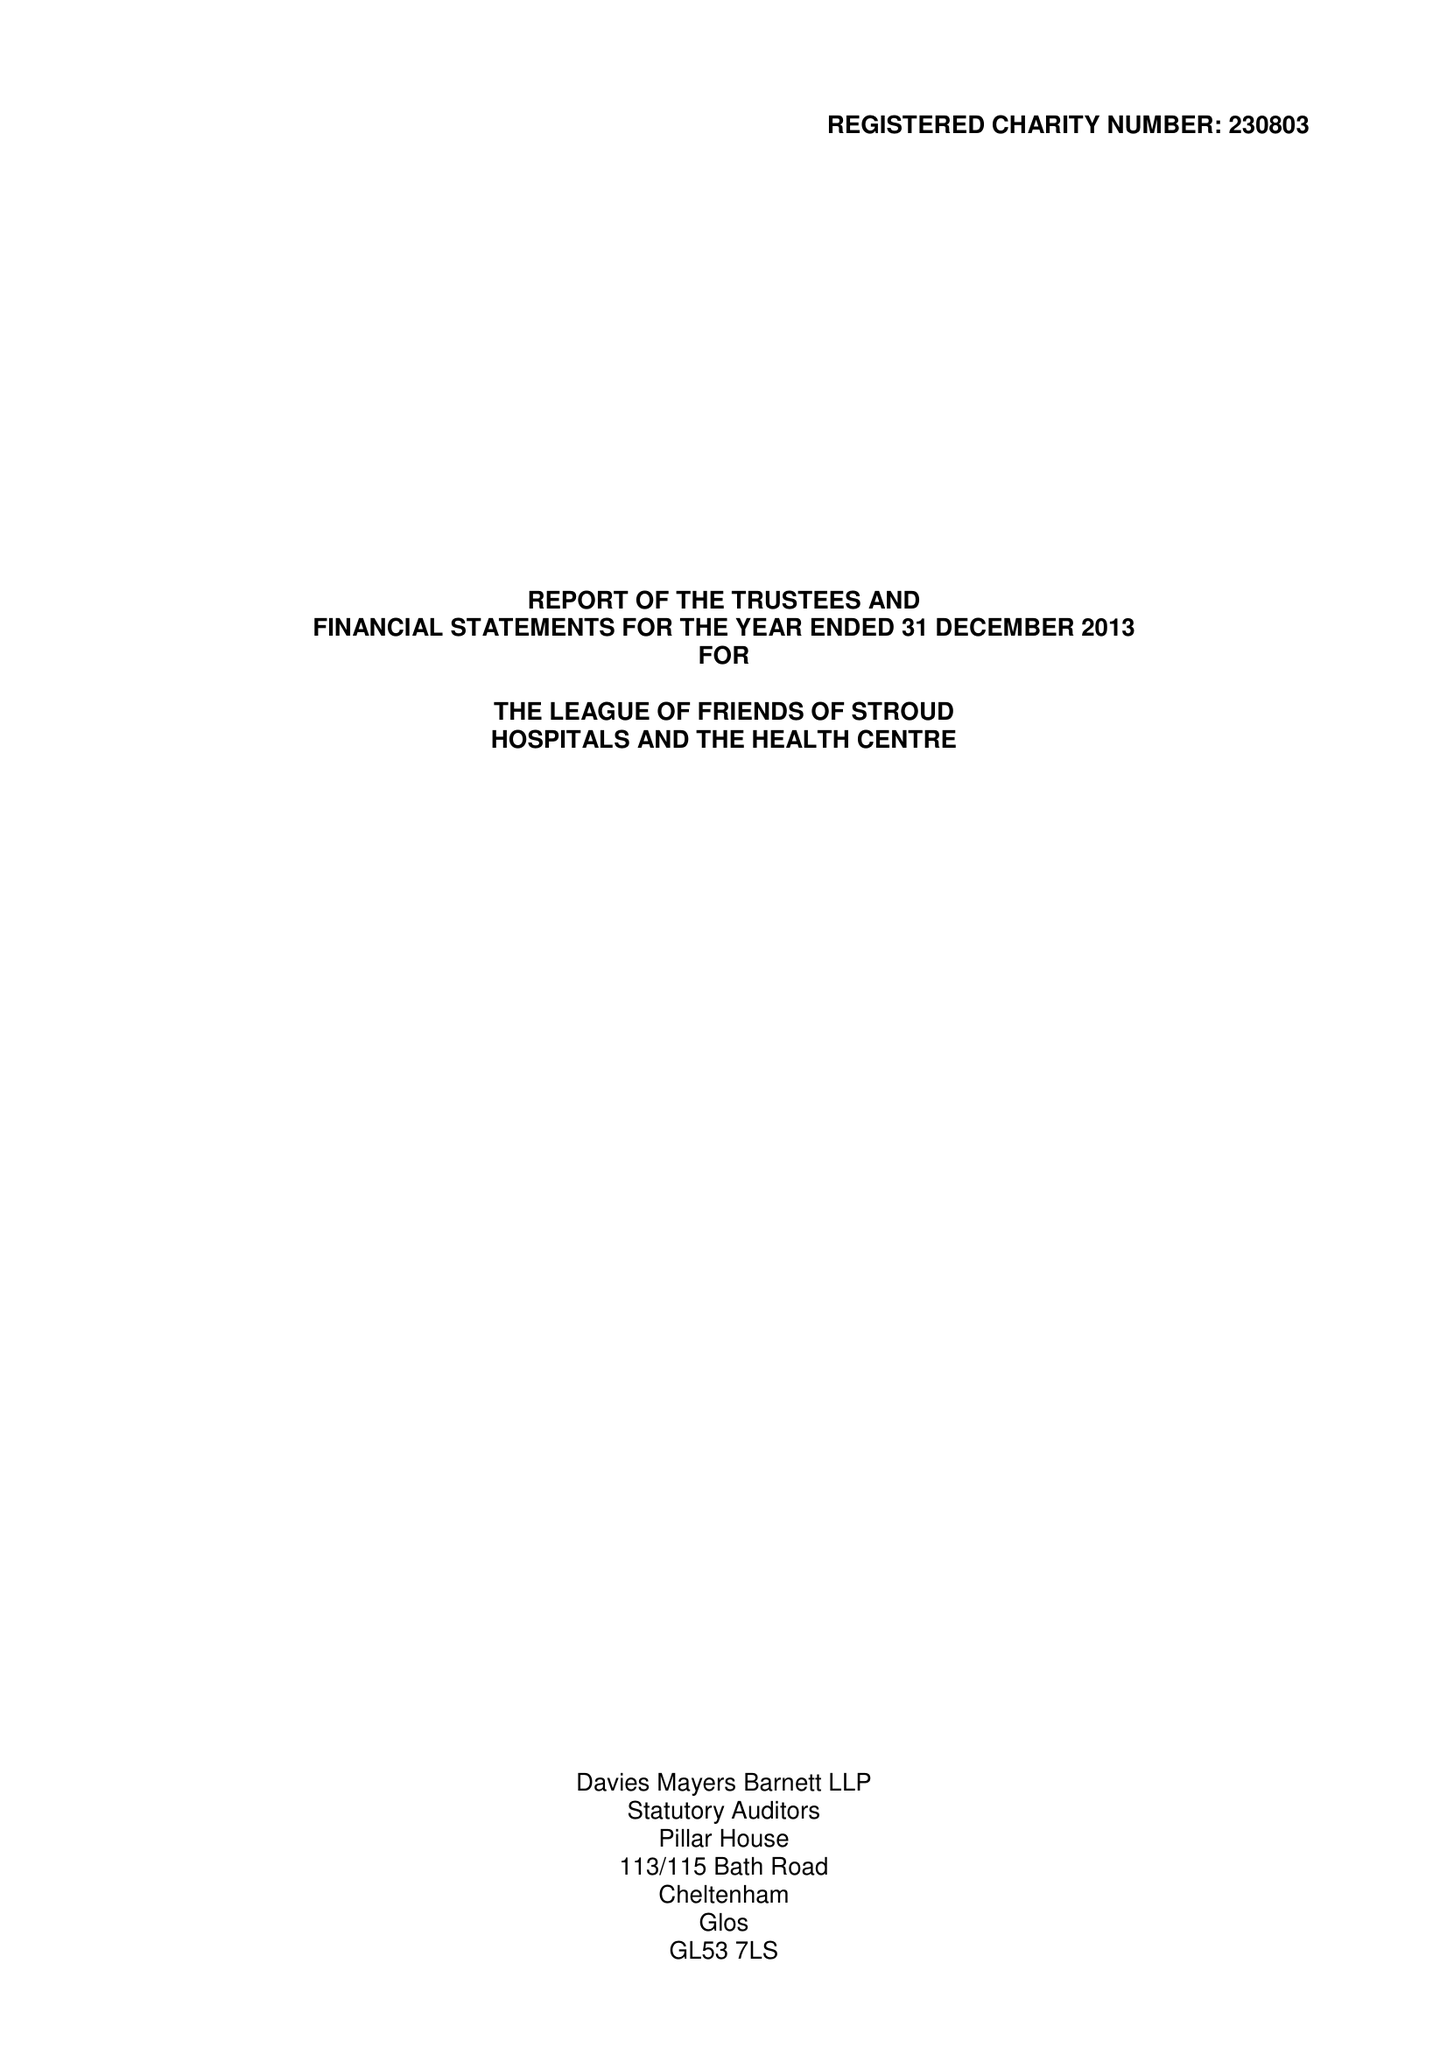What is the value for the charity_name?
Answer the question using a single word or phrase. The League Of Friends Of Stroud Hospitals and The Health Centre 